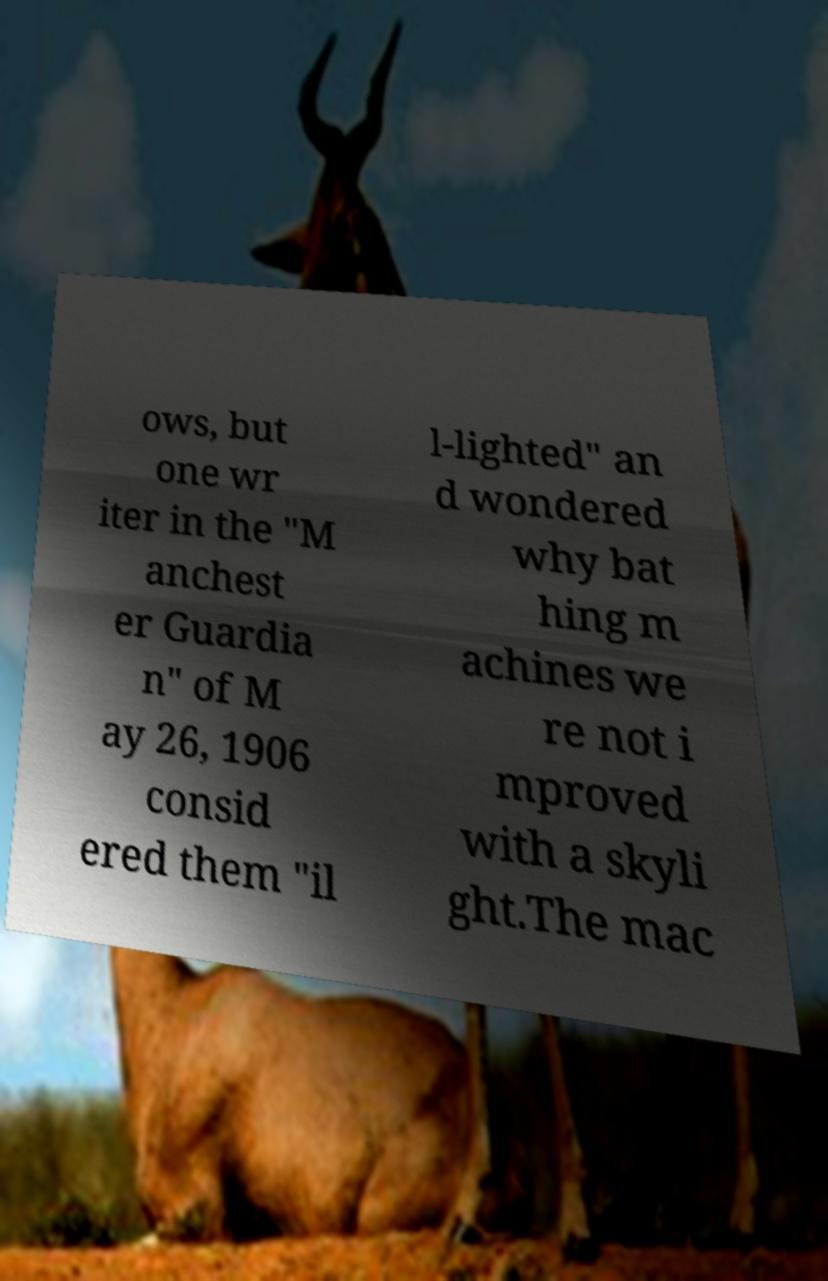Please read and relay the text visible in this image. What does it say? ows, but one wr iter in the "M anchest er Guardia n" of M ay 26, 1906 consid ered them "il l-lighted" an d wondered why bat hing m achines we re not i mproved with a skyli ght.The mac 